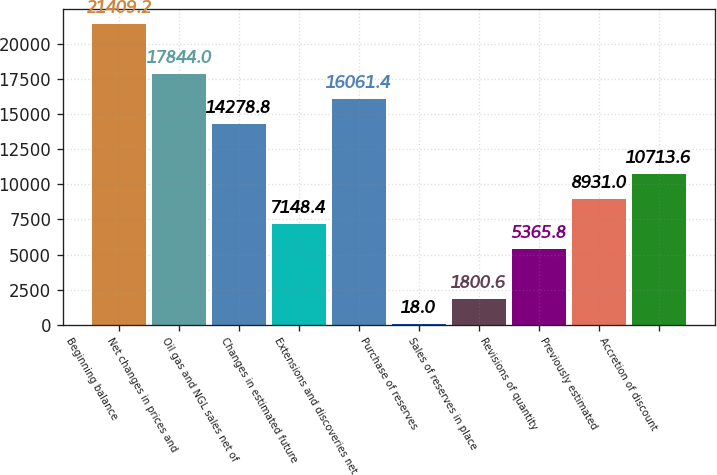Convert chart to OTSL. <chart><loc_0><loc_0><loc_500><loc_500><bar_chart><fcel>Beginning balance<fcel>Net changes in prices and<fcel>Oil gas and NGL sales net of<fcel>Changes in estimated future<fcel>Extensions and discoveries net<fcel>Purchase of reserves<fcel>Sales of reserves in place<fcel>Revisions of quantity<fcel>Previously estimated<fcel>Accretion of discount<nl><fcel>21409.2<fcel>17844<fcel>14278.8<fcel>7148.4<fcel>16061.4<fcel>18<fcel>1800.6<fcel>5365.8<fcel>8931<fcel>10713.6<nl></chart> 